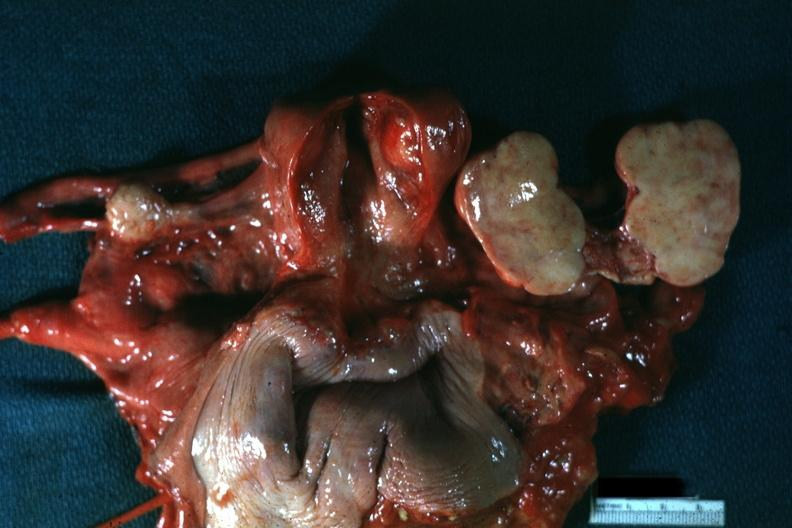what does this image show?
Answer the question using a single word or phrase. All pelvic organs tumor mass opened like a book typical for lesion 